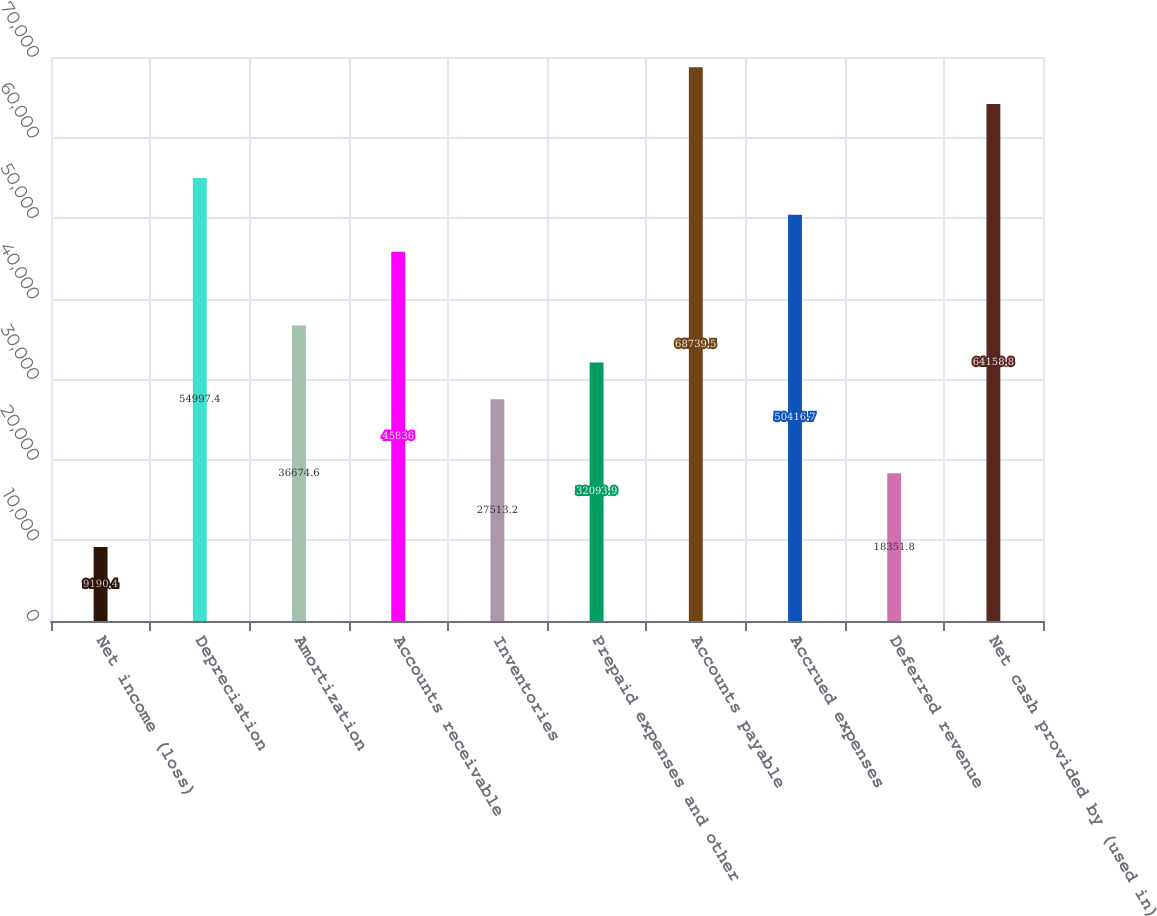<chart> <loc_0><loc_0><loc_500><loc_500><bar_chart><fcel>Net income (loss)<fcel>Depreciation<fcel>Amortization<fcel>Accounts receivable<fcel>Inventories<fcel>Prepaid expenses and other<fcel>Accounts payable<fcel>Accrued expenses<fcel>Deferred revenue<fcel>Net cash provided by (used in)<nl><fcel>9190.4<fcel>54997.4<fcel>36674.6<fcel>45836<fcel>27513.2<fcel>32093.9<fcel>68739.5<fcel>50416.7<fcel>18351.8<fcel>64158.8<nl></chart> 